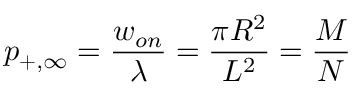<formula> <loc_0><loc_0><loc_500><loc_500>p _ { + , \infty } = { \frac { w _ { o n } } { \lambda } } = { \frac { \pi R ^ { 2 } } { L ^ { 2 } } } = { \frac { M } { N } }</formula> 